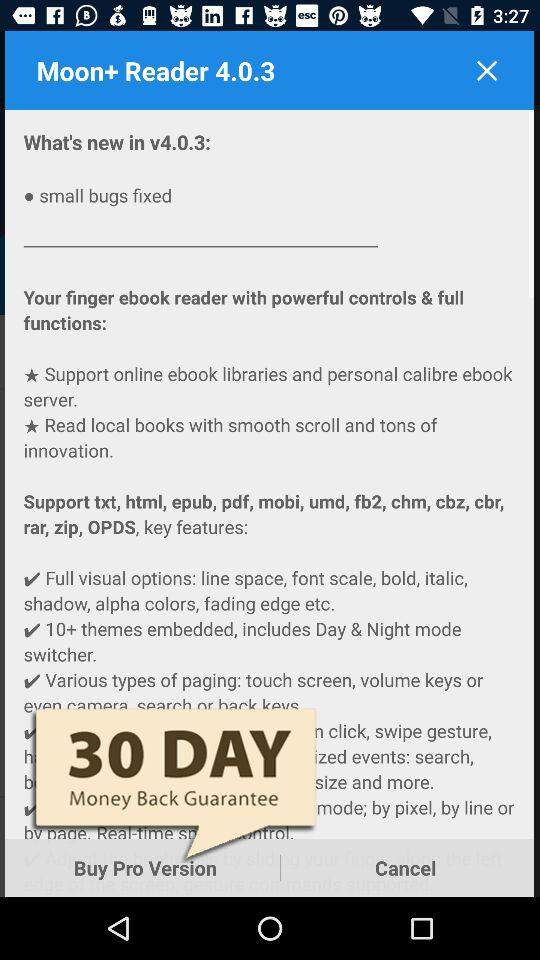What is the version? The version is "v4.0.3". 